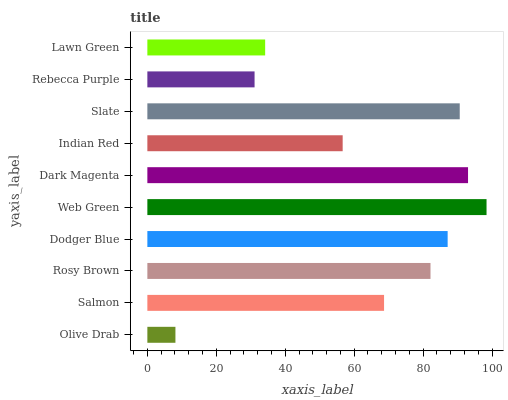Is Olive Drab the minimum?
Answer yes or no. Yes. Is Web Green the maximum?
Answer yes or no. Yes. Is Salmon the minimum?
Answer yes or no. No. Is Salmon the maximum?
Answer yes or no. No. Is Salmon greater than Olive Drab?
Answer yes or no. Yes. Is Olive Drab less than Salmon?
Answer yes or no. Yes. Is Olive Drab greater than Salmon?
Answer yes or no. No. Is Salmon less than Olive Drab?
Answer yes or no. No. Is Rosy Brown the high median?
Answer yes or no. Yes. Is Salmon the low median?
Answer yes or no. Yes. Is Dodger Blue the high median?
Answer yes or no. No. Is Indian Red the low median?
Answer yes or no. No. 